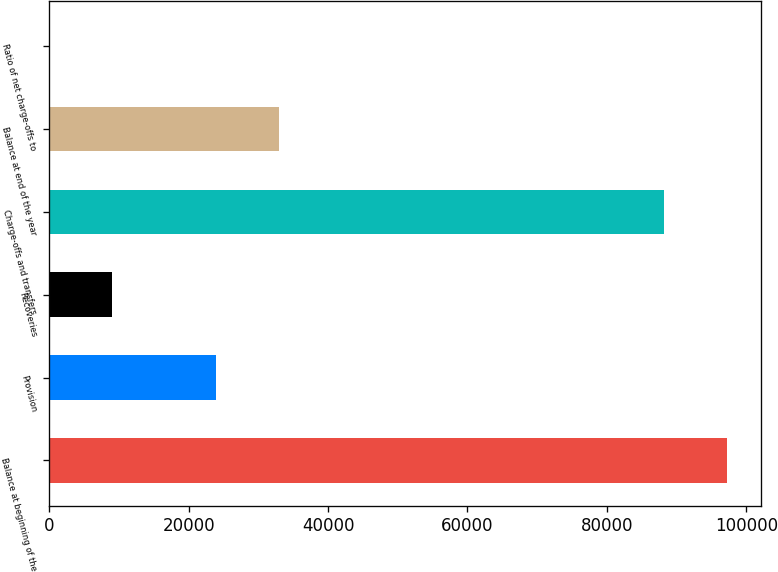Convert chart to OTSL. <chart><loc_0><loc_0><loc_500><loc_500><bar_chart><fcel>Balance at beginning of the<fcel>Provision<fcel>Recoveries<fcel>Charge-offs and transfers<fcel>Balance at end of the year<fcel>Ratio of net charge-offs to<nl><fcel>97216.7<fcel>23875<fcel>9066.35<fcel>88170<fcel>32921.7<fcel>19.61<nl></chart> 